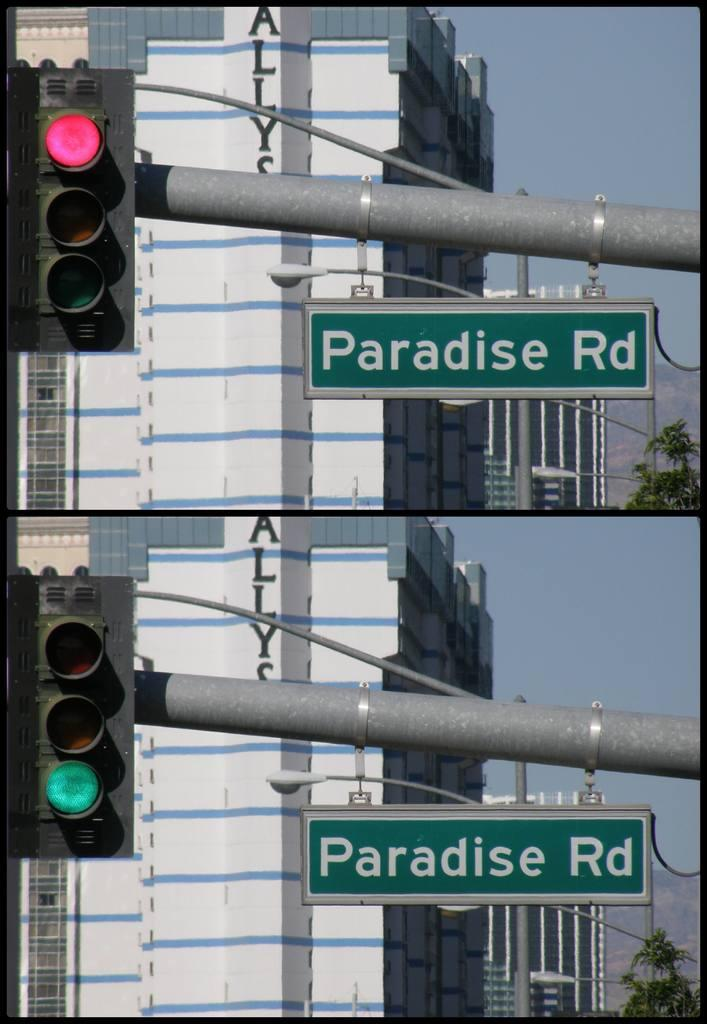<image>
Offer a succinct explanation of the picture presented. The signal at Paradise Rd is working properly. 